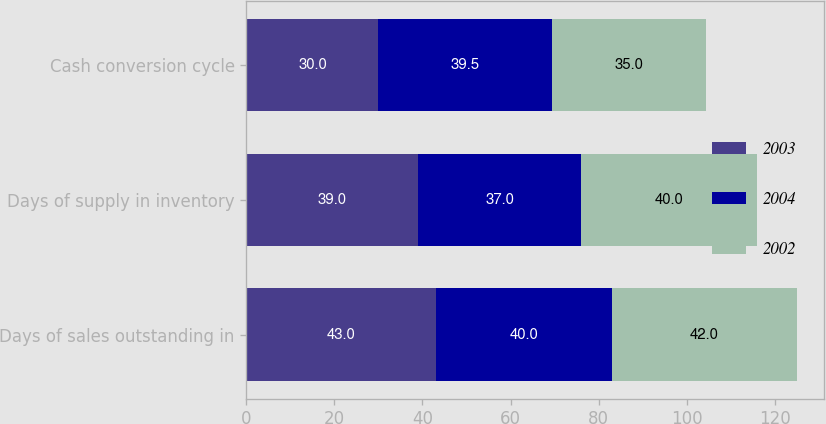Convert chart to OTSL. <chart><loc_0><loc_0><loc_500><loc_500><stacked_bar_chart><ecel><fcel>Days of sales outstanding in<fcel>Days of supply in inventory<fcel>Cash conversion cycle<nl><fcel>2003<fcel>43<fcel>39<fcel>30<nl><fcel>2004<fcel>40<fcel>37<fcel>39.5<nl><fcel>2002<fcel>42<fcel>40<fcel>35<nl></chart> 